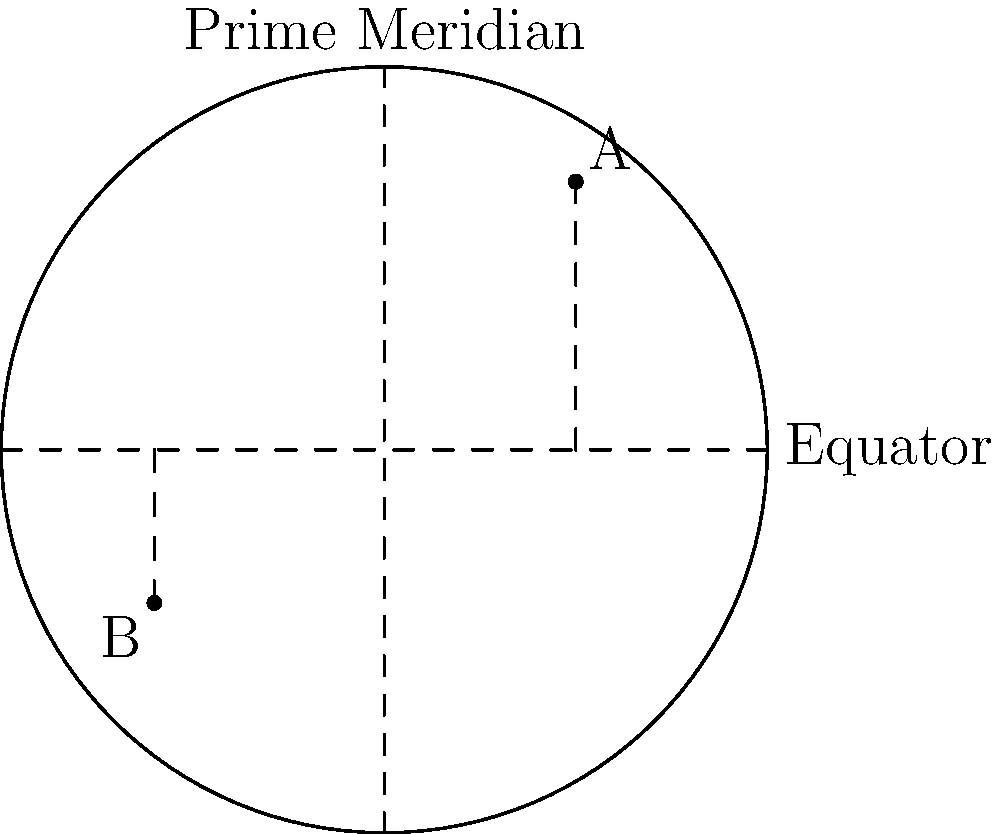Two points A and B are located on a map as shown. Point A has coordinates (30°N, 45°E) and point B has coordinates (23°S, 34°W). Given that the Earth's radius is approximately 6,371 km, calculate the shortest distance between these two points along the Earth's surface using the Haversine formula. To solve this problem, we'll use the Haversine formula:

$$ d = 2R \arcsin\left(\sqrt{\sin^2\left(\frac{\Delta\phi}{2}\right) + \cos\phi_1 \cos\phi_2 \sin^2\left(\frac{\Delta\lambda}{2}\right)}\right) $$

Where:
- $d$ is the distance between the two points along a great circle of the Earth
- $R$ is the radius of the Earth (6,371 km)
- $\phi_1, \phi_2$ are the latitudes of point 1 and point 2 in radians
- $\Delta\phi$ is the difference in latitude
- $\Delta\lambda$ is the difference in longitude

Step 1: Convert latitudes and longitudes to radians
$\phi_1 = 30° \cdot \frac{\pi}{180} = 0.5236$ rad
$\phi_2 = -23° \cdot \frac{\pi}{180} = -0.4014$ rad
$\lambda_1 = 45° \cdot \frac{\pi}{180} = 0.7854$ rad
$\lambda_2 = -34° \cdot \frac{\pi}{180} = -0.5934$ rad

Step 2: Calculate differences
$\Delta\phi = \phi_2 - \phi_1 = -0.4014 - 0.5236 = -0.9250$ rad
$\Delta\lambda = \lambda_2 - \lambda_1 = -0.5934 - 0.7854 = -1.3788$ rad

Step 3: Apply the Haversine formula
$$ d = 2 \cdot 6371 \cdot \arcsin\left(\sqrt{\sin^2\left(\frac{-0.9250}{2}\right) + \cos(0.5236) \cos(-0.4014) \sin^2\left(\frac{-1.3788}{2}\right)}\right) $$

Step 4: Calculate the result
$d \approx 8,854.45$ km
Answer: 8,854 km 